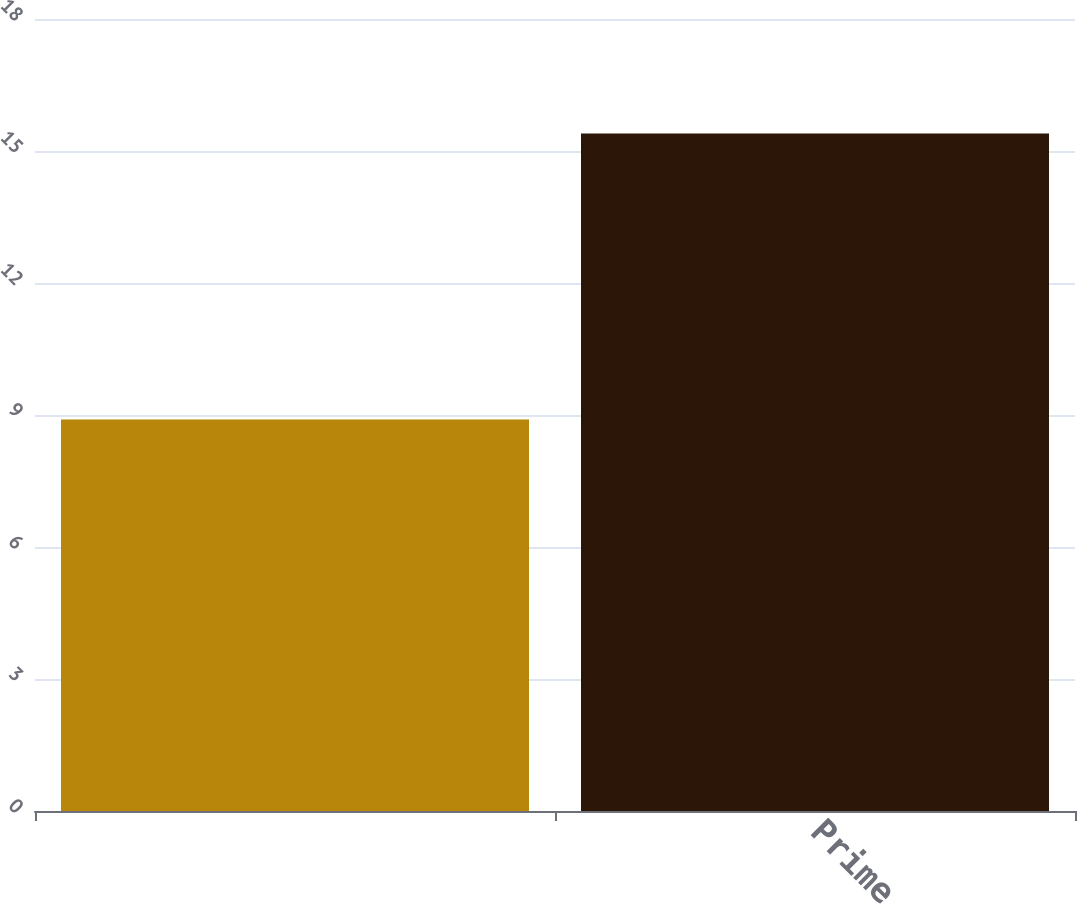Convert chart to OTSL. <chart><loc_0><loc_0><loc_500><loc_500><bar_chart><ecel><fcel>Prime<nl><fcel>8.9<fcel>15.4<nl></chart> 